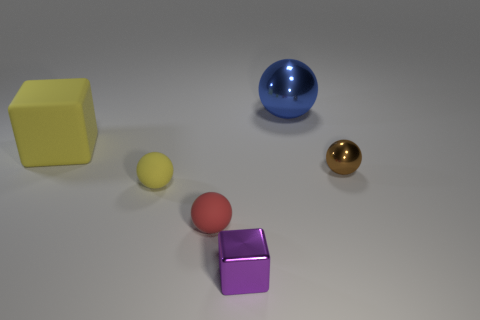Add 2 small yellow objects. How many objects exist? 8 Subtract all small brown metallic spheres. How many spheres are left? 3 Subtract all purple blocks. How many blocks are left? 1 Subtract 1 balls. How many balls are left? 3 Subtract all purple cubes. Subtract all red cylinders. How many cubes are left? 1 Subtract all brown spheres. How many red cubes are left? 0 Subtract all small red spheres. Subtract all small gray balls. How many objects are left? 5 Add 1 purple cubes. How many purple cubes are left? 2 Add 2 yellow cubes. How many yellow cubes exist? 3 Subtract 0 cyan cylinders. How many objects are left? 6 